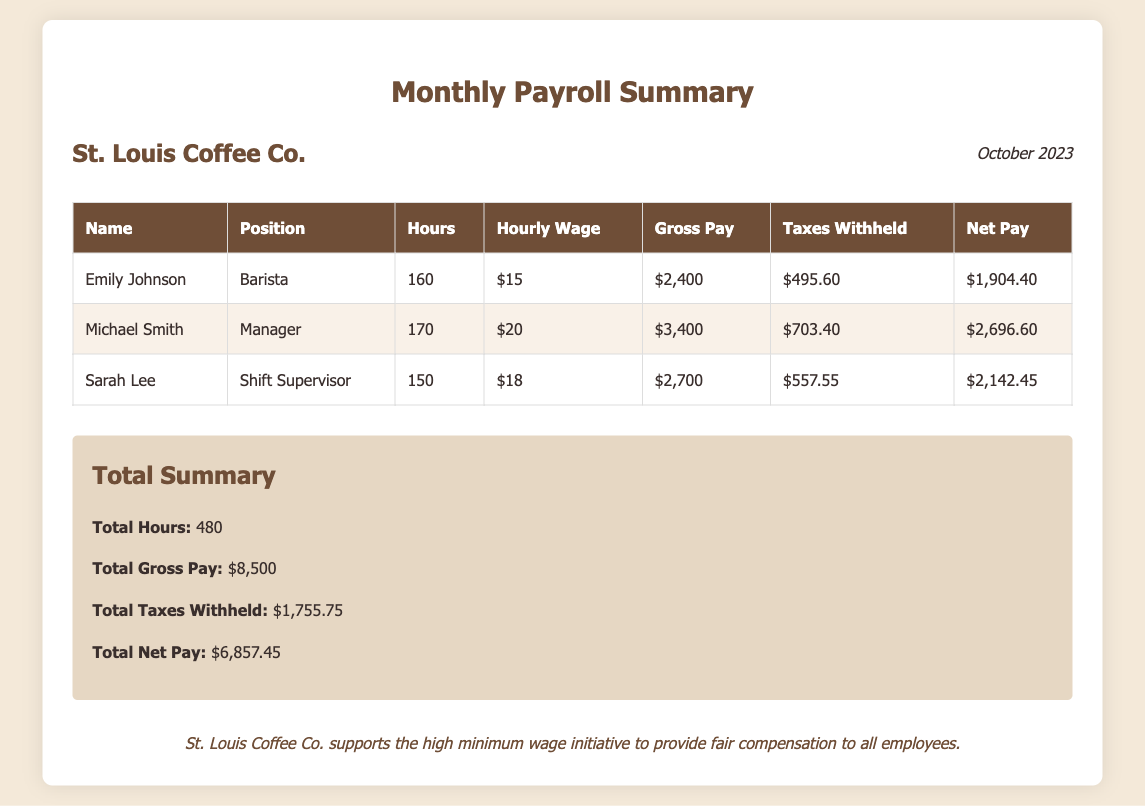What is the total number of hours worked? The total number of hours worked can be found in the total summary section, which lists total hours as 480.
Answer: 480 What is Sarah Lee's hourly wage? Sarah Lee’s hourly wage is listed in her row under 'Hourly Wage' as $18.
Answer: $18 Who is the Shift Supervisor? The document specifies that Sarah Lee holds the position of Shift Supervisor.
Answer: Sarah Lee What is the total taxes withheld? The document provides the total taxes withheld in the summary section as $1,755.75.
Answer: $1,755.75 What is Emily Johnson’s net pay? Emily Johnson’s net pay is stated in her row under 'Net Pay' as $1,904.40.
Answer: $1,904.40 How much gross pay did Michael Smith earn? Michael Smith's gross pay is shown in his row as $3,400.
Answer: $3,400 What is the total net pay for all employees? The total net pay is indicated in the summary section as $6,857.45.
Answer: $6,857.45 What month does this payroll summary cover? The document is dated for October 2023, as indicated in the header.
Answer: October 2023 What position does Emily Johnson hold? The document shows that Emily Johnson is a Barista, as noted in her row under 'Position'.
Answer: Barista 